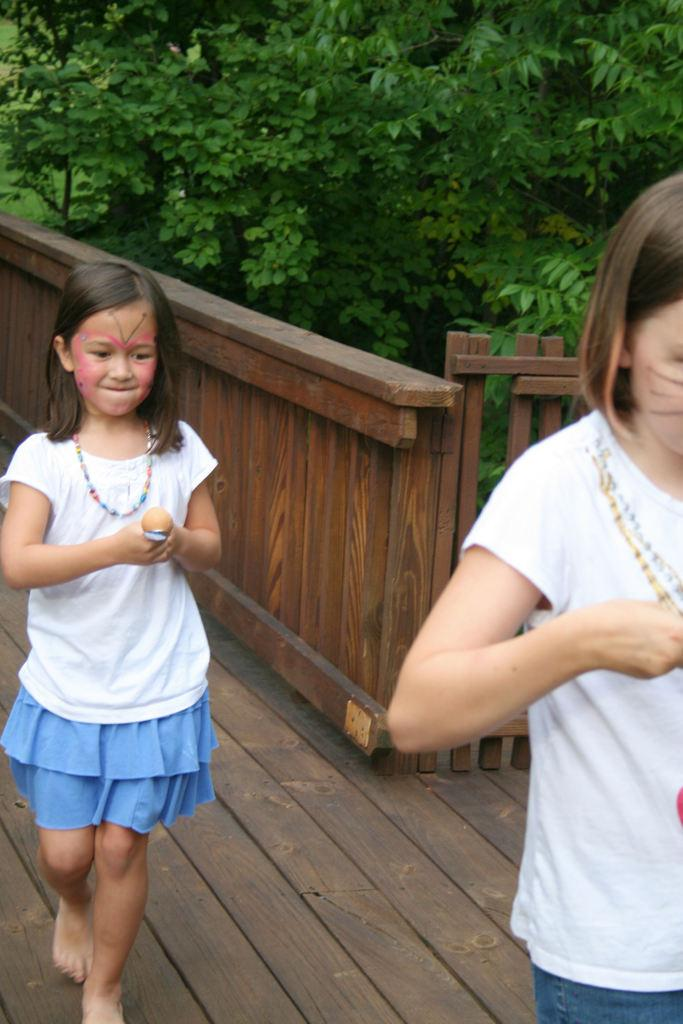How many people are in the image? There are two girls in the image. What are the girls doing in the image? The girls are walking. What are the girls holding in their hands? The girls are holding spoons. What can be seen in the background of the image? There is a fence and trees visible in the background of the image. Where is the uncle sitting in the image? There is no uncle present in the image. What type of joke is being told by the girls in the image? There is no joke being told in the image; the girls are simply walking and holding spoons. 